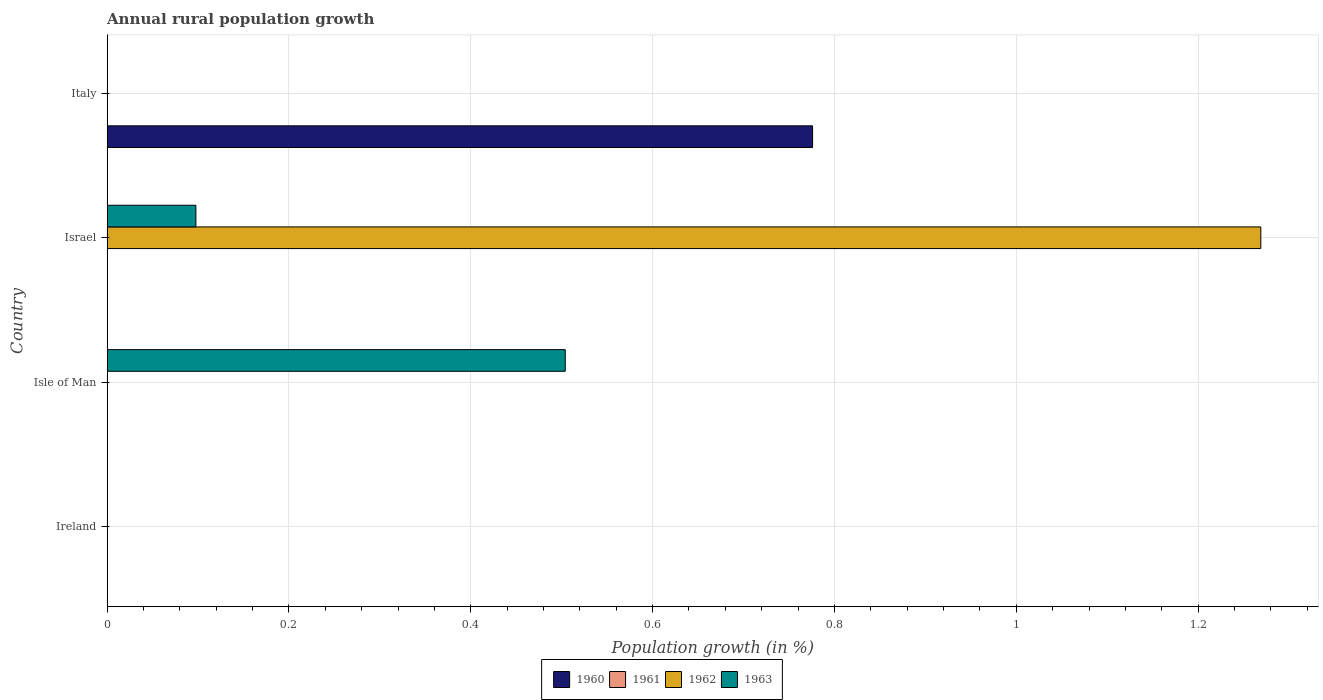Are the number of bars per tick equal to the number of legend labels?
Your response must be concise. No. What is the label of the 4th group of bars from the top?
Your answer should be very brief. Ireland. Across all countries, what is the maximum percentage of rural population growth in 1962?
Keep it short and to the point. 1.27. Across all countries, what is the minimum percentage of rural population growth in 1961?
Your response must be concise. 0. In which country was the percentage of rural population growth in 1963 maximum?
Give a very brief answer. Isle of Man. What is the total percentage of rural population growth in 1963 in the graph?
Your response must be concise. 0.6. What is the difference between the percentage of rural population growth in 1960 in Ireland and the percentage of rural population growth in 1963 in Isle of Man?
Offer a very short reply. -0.5. What is the average percentage of rural population growth in 1963 per country?
Your answer should be compact. 0.15. In how many countries, is the percentage of rural population growth in 1962 greater than 0.24000000000000002 %?
Offer a very short reply. 1. What is the difference between the highest and the lowest percentage of rural population growth in 1962?
Your answer should be very brief. 1.27. Is it the case that in every country, the sum of the percentage of rural population growth in 1963 and percentage of rural population growth in 1961 is greater than the sum of percentage of rural population growth in 1960 and percentage of rural population growth in 1962?
Provide a succinct answer. No. How many bars are there?
Provide a short and direct response. 4. Are all the bars in the graph horizontal?
Your answer should be compact. Yes. What is the difference between two consecutive major ticks on the X-axis?
Provide a short and direct response. 0.2. Does the graph contain any zero values?
Your response must be concise. Yes. Where does the legend appear in the graph?
Provide a short and direct response. Bottom center. What is the title of the graph?
Your answer should be compact. Annual rural population growth. Does "1990" appear as one of the legend labels in the graph?
Provide a succinct answer. No. What is the label or title of the X-axis?
Ensure brevity in your answer.  Population growth (in %). What is the label or title of the Y-axis?
Provide a succinct answer. Country. What is the Population growth (in %) of 1962 in Ireland?
Ensure brevity in your answer.  0. What is the Population growth (in %) of 1960 in Isle of Man?
Your response must be concise. 0. What is the Population growth (in %) of 1963 in Isle of Man?
Offer a very short reply. 0.5. What is the Population growth (in %) in 1960 in Israel?
Keep it short and to the point. 0. What is the Population growth (in %) of 1962 in Israel?
Provide a short and direct response. 1.27. What is the Population growth (in %) of 1963 in Israel?
Make the answer very short. 0.1. What is the Population growth (in %) of 1960 in Italy?
Provide a short and direct response. 0.78. What is the Population growth (in %) of 1961 in Italy?
Your response must be concise. 0. What is the Population growth (in %) in 1962 in Italy?
Offer a terse response. 0. Across all countries, what is the maximum Population growth (in %) in 1960?
Provide a succinct answer. 0.78. Across all countries, what is the maximum Population growth (in %) in 1962?
Make the answer very short. 1.27. Across all countries, what is the maximum Population growth (in %) of 1963?
Give a very brief answer. 0.5. What is the total Population growth (in %) of 1960 in the graph?
Your response must be concise. 0.78. What is the total Population growth (in %) in 1961 in the graph?
Provide a short and direct response. 0. What is the total Population growth (in %) in 1962 in the graph?
Provide a short and direct response. 1.27. What is the total Population growth (in %) of 1963 in the graph?
Your answer should be compact. 0.6. What is the difference between the Population growth (in %) in 1963 in Isle of Man and that in Israel?
Make the answer very short. 0.41. What is the average Population growth (in %) of 1960 per country?
Give a very brief answer. 0.19. What is the average Population growth (in %) in 1961 per country?
Make the answer very short. 0. What is the average Population growth (in %) of 1962 per country?
Offer a very short reply. 0.32. What is the average Population growth (in %) of 1963 per country?
Keep it short and to the point. 0.15. What is the difference between the Population growth (in %) in 1962 and Population growth (in %) in 1963 in Israel?
Offer a very short reply. 1.17. What is the ratio of the Population growth (in %) of 1963 in Isle of Man to that in Israel?
Offer a very short reply. 5.16. What is the difference between the highest and the lowest Population growth (in %) of 1960?
Keep it short and to the point. 0.78. What is the difference between the highest and the lowest Population growth (in %) in 1962?
Give a very brief answer. 1.27. What is the difference between the highest and the lowest Population growth (in %) of 1963?
Offer a very short reply. 0.5. 